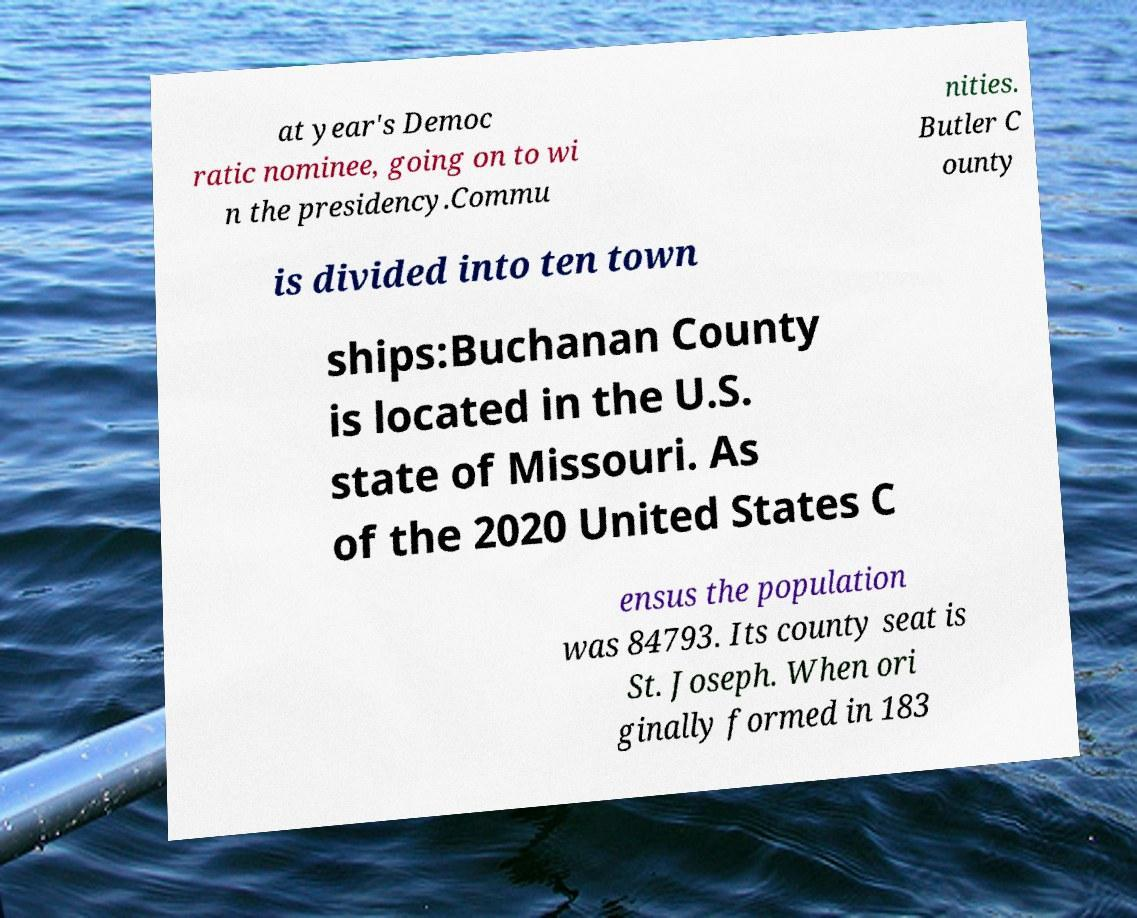What messages or text are displayed in this image? I need them in a readable, typed format. at year's Democ ratic nominee, going on to wi n the presidency.Commu nities. Butler C ounty is divided into ten town ships:Buchanan County is located in the U.S. state of Missouri. As of the 2020 United States C ensus the population was 84793. Its county seat is St. Joseph. When ori ginally formed in 183 